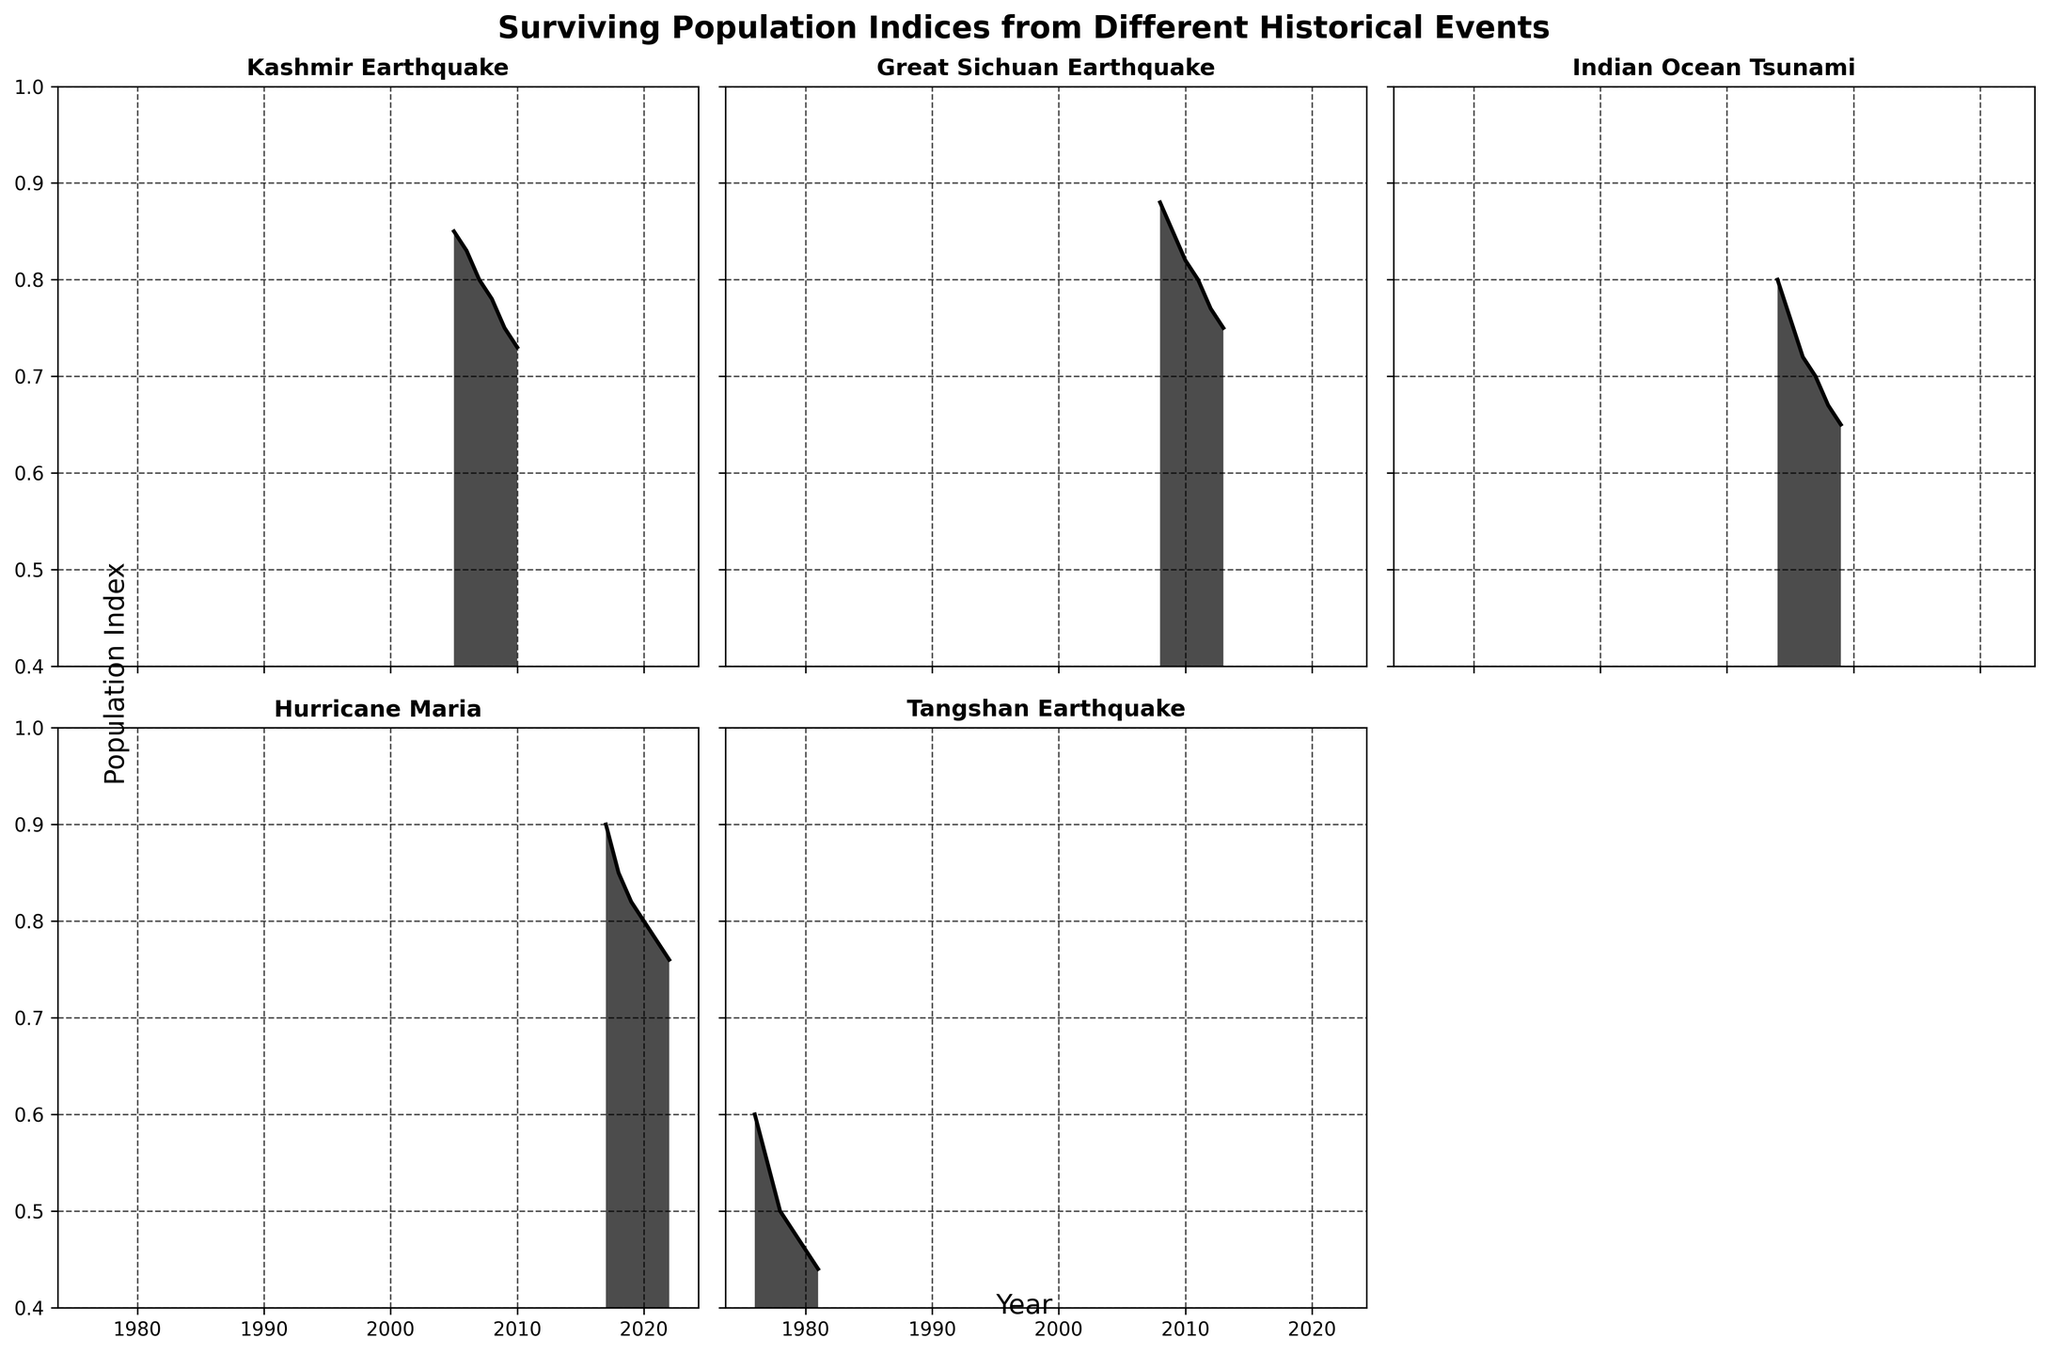what is the highest population index for the Tangshan Earthquake subplot? The Tangshan Earthquake subplot shows the population index starting in 1976 at 0.60, and the maximum of the visible data points on the chart is this initial value.
Answer: 0.60 which event retained the highest population index by 2022? Looking at all subplots, the population index for Hurricane Maria is the highest by 2022, ending at 0.76. The other events have lower population indices at their respective end years.
Answer: Hurricane Maria In which year did the Indian Ocean Tsunami population index drop below 0.7? On the Indian Ocean Tsunami subplot, the population index drops below 0.7 in the year 2007, as the index value for 2006 is 0.72 and for 2007 is 0.70, which is still above 0.7, and in 2008 it is 0.67 which is below 0.7.
Answer: 2008 Compare the rate of decline in population index between the Kashmir and Great Sichuan Earthquakes. Which one declined faster initially? By comparing the slopes of both subplots, it is evident that the Kashmir Earthquake subplot shows a slightly steeper decline initially. From 2005 to 2010, the Kashmir index declines from 0.85 to 0.73, while the Great Sichuan Earthquake from 2008 to 2013 goes from 0.88 to 0.75. Therefore, the Kashmir Earthquake declined faster initially.
Answer: Kashmir Earthquake Identify the event with the steepest continuous decline in population index over the years shown. Evaluating the slopes of each subplot, the Tangshan Earthquake has the steepest continuous decline. It drops from 0.60 in 1976 to 0.44 in 1981.
Answer: Tangshan Earthquake what is the average population index for the Great Sichuan Earthquake during the years shown? Summing the population indices for each year in the Great Sichuan subplot: 0.88 + 0.85 + 0.82 + 0.80 + 0.77 + 0.75, then divide by the number of years (6): (0.88 + 0.85 + 0.82 + 0.80 + 0.77 + 0.75)/6 ≈ 0.81
Answer: 0.81 